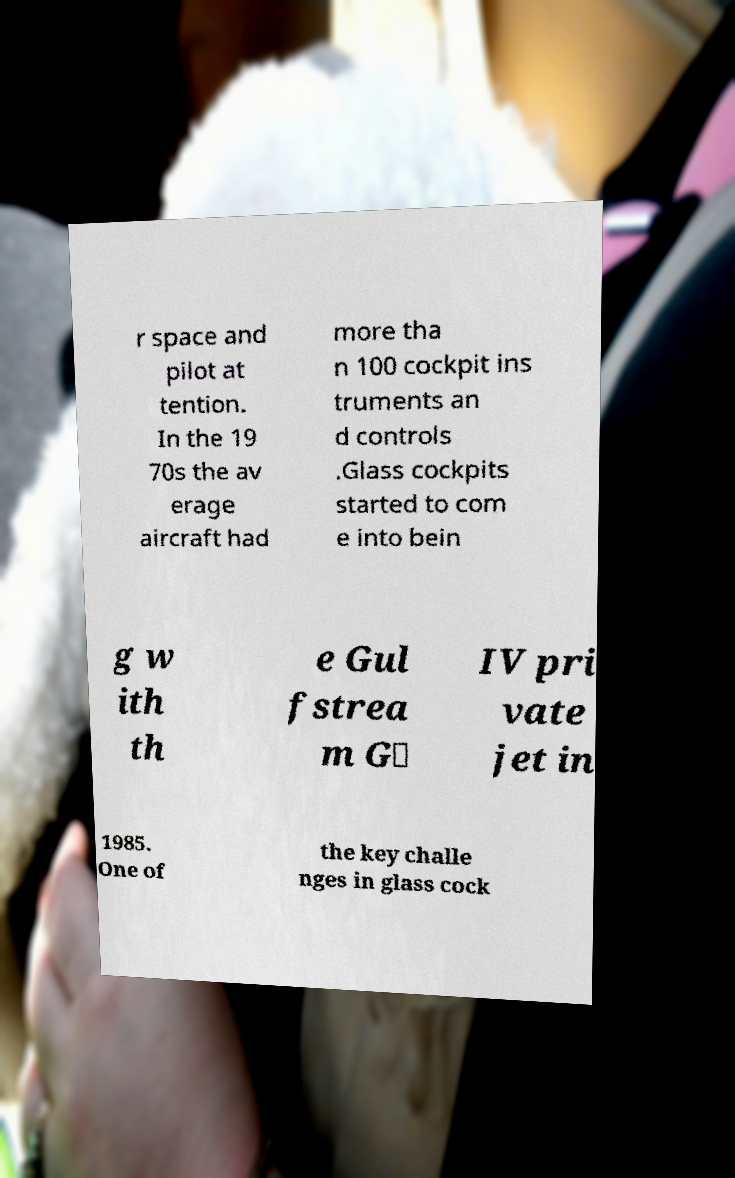Can you read and provide the text displayed in the image?This photo seems to have some interesting text. Can you extract and type it out for me? r space and pilot at tention. In the 19 70s the av erage aircraft had more tha n 100 cockpit ins truments an d controls .Glass cockpits started to com e into bein g w ith th e Gul fstrea m G‑ IV pri vate jet in 1985. One of the key challe nges in glass cock 